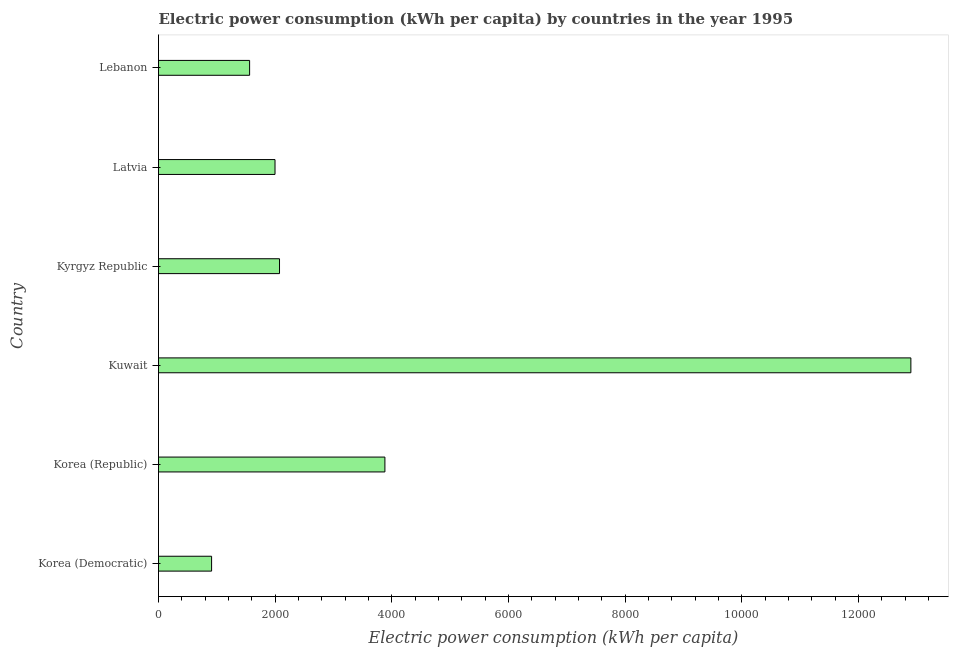Does the graph contain any zero values?
Your answer should be very brief. No. What is the title of the graph?
Make the answer very short. Electric power consumption (kWh per capita) by countries in the year 1995. What is the label or title of the X-axis?
Offer a very short reply. Electric power consumption (kWh per capita). What is the label or title of the Y-axis?
Your answer should be compact. Country. What is the electric power consumption in Latvia?
Provide a succinct answer. 1997.14. Across all countries, what is the maximum electric power consumption?
Offer a very short reply. 1.29e+04. Across all countries, what is the minimum electric power consumption?
Ensure brevity in your answer.  910.05. In which country was the electric power consumption maximum?
Keep it short and to the point. Kuwait. In which country was the electric power consumption minimum?
Offer a very short reply. Korea (Democratic). What is the sum of the electric power consumption?
Give a very brief answer. 2.33e+04. What is the difference between the electric power consumption in Korea (Republic) and Kuwait?
Offer a terse response. -9016.72. What is the average electric power consumption per country?
Offer a very short reply. 3886.99. What is the median electric power consumption?
Offer a terse response. 2035.76. In how many countries, is the electric power consumption greater than 5600 kWh per capita?
Provide a succinct answer. 1. What is the ratio of the electric power consumption in Korea (Republic) to that in Kuwait?
Offer a terse response. 0.3. Is the difference between the electric power consumption in Korea (Republic) and Kyrgyz Republic greater than the difference between any two countries?
Offer a terse response. No. What is the difference between the highest and the second highest electric power consumption?
Provide a short and direct response. 9016.72. What is the difference between the highest and the lowest electric power consumption?
Offer a terse response. 1.20e+04. In how many countries, is the electric power consumption greater than the average electric power consumption taken over all countries?
Offer a terse response. 1. How many bars are there?
Offer a very short reply. 6. Are all the bars in the graph horizontal?
Make the answer very short. Yes. How many countries are there in the graph?
Provide a short and direct response. 6. What is the Electric power consumption (kWh per capita) of Korea (Democratic)?
Give a very brief answer. 910.05. What is the Electric power consumption (kWh per capita) in Korea (Republic)?
Offer a terse response. 3881.02. What is the Electric power consumption (kWh per capita) of Kuwait?
Offer a terse response. 1.29e+04. What is the Electric power consumption (kWh per capita) in Kyrgyz Republic?
Make the answer very short. 2074.38. What is the Electric power consumption (kWh per capita) of Latvia?
Keep it short and to the point. 1997.14. What is the Electric power consumption (kWh per capita) in Lebanon?
Keep it short and to the point. 1561.61. What is the difference between the Electric power consumption (kWh per capita) in Korea (Democratic) and Korea (Republic)?
Provide a succinct answer. -2970.98. What is the difference between the Electric power consumption (kWh per capita) in Korea (Democratic) and Kuwait?
Your response must be concise. -1.20e+04. What is the difference between the Electric power consumption (kWh per capita) in Korea (Democratic) and Kyrgyz Republic?
Give a very brief answer. -1164.33. What is the difference between the Electric power consumption (kWh per capita) in Korea (Democratic) and Latvia?
Offer a terse response. -1087.09. What is the difference between the Electric power consumption (kWh per capita) in Korea (Democratic) and Lebanon?
Provide a succinct answer. -651.56. What is the difference between the Electric power consumption (kWh per capita) in Korea (Republic) and Kuwait?
Your response must be concise. -9016.72. What is the difference between the Electric power consumption (kWh per capita) in Korea (Republic) and Kyrgyz Republic?
Make the answer very short. 1806.64. What is the difference between the Electric power consumption (kWh per capita) in Korea (Republic) and Latvia?
Your answer should be compact. 1883.89. What is the difference between the Electric power consumption (kWh per capita) in Korea (Republic) and Lebanon?
Your response must be concise. 2319.41. What is the difference between the Electric power consumption (kWh per capita) in Kuwait and Kyrgyz Republic?
Make the answer very short. 1.08e+04. What is the difference between the Electric power consumption (kWh per capita) in Kuwait and Latvia?
Provide a short and direct response. 1.09e+04. What is the difference between the Electric power consumption (kWh per capita) in Kuwait and Lebanon?
Provide a short and direct response. 1.13e+04. What is the difference between the Electric power consumption (kWh per capita) in Kyrgyz Republic and Latvia?
Make the answer very short. 77.24. What is the difference between the Electric power consumption (kWh per capita) in Kyrgyz Republic and Lebanon?
Provide a short and direct response. 512.77. What is the difference between the Electric power consumption (kWh per capita) in Latvia and Lebanon?
Provide a succinct answer. 435.53. What is the ratio of the Electric power consumption (kWh per capita) in Korea (Democratic) to that in Korea (Republic)?
Offer a very short reply. 0.23. What is the ratio of the Electric power consumption (kWh per capita) in Korea (Democratic) to that in Kuwait?
Keep it short and to the point. 0.07. What is the ratio of the Electric power consumption (kWh per capita) in Korea (Democratic) to that in Kyrgyz Republic?
Your answer should be very brief. 0.44. What is the ratio of the Electric power consumption (kWh per capita) in Korea (Democratic) to that in Latvia?
Keep it short and to the point. 0.46. What is the ratio of the Electric power consumption (kWh per capita) in Korea (Democratic) to that in Lebanon?
Your answer should be compact. 0.58. What is the ratio of the Electric power consumption (kWh per capita) in Korea (Republic) to that in Kuwait?
Keep it short and to the point. 0.3. What is the ratio of the Electric power consumption (kWh per capita) in Korea (Republic) to that in Kyrgyz Republic?
Provide a short and direct response. 1.87. What is the ratio of the Electric power consumption (kWh per capita) in Korea (Republic) to that in Latvia?
Make the answer very short. 1.94. What is the ratio of the Electric power consumption (kWh per capita) in Korea (Republic) to that in Lebanon?
Give a very brief answer. 2.48. What is the ratio of the Electric power consumption (kWh per capita) in Kuwait to that in Kyrgyz Republic?
Make the answer very short. 6.22. What is the ratio of the Electric power consumption (kWh per capita) in Kuwait to that in Latvia?
Ensure brevity in your answer.  6.46. What is the ratio of the Electric power consumption (kWh per capita) in Kuwait to that in Lebanon?
Make the answer very short. 8.26. What is the ratio of the Electric power consumption (kWh per capita) in Kyrgyz Republic to that in Latvia?
Provide a succinct answer. 1.04. What is the ratio of the Electric power consumption (kWh per capita) in Kyrgyz Republic to that in Lebanon?
Provide a succinct answer. 1.33. What is the ratio of the Electric power consumption (kWh per capita) in Latvia to that in Lebanon?
Your answer should be compact. 1.28. 